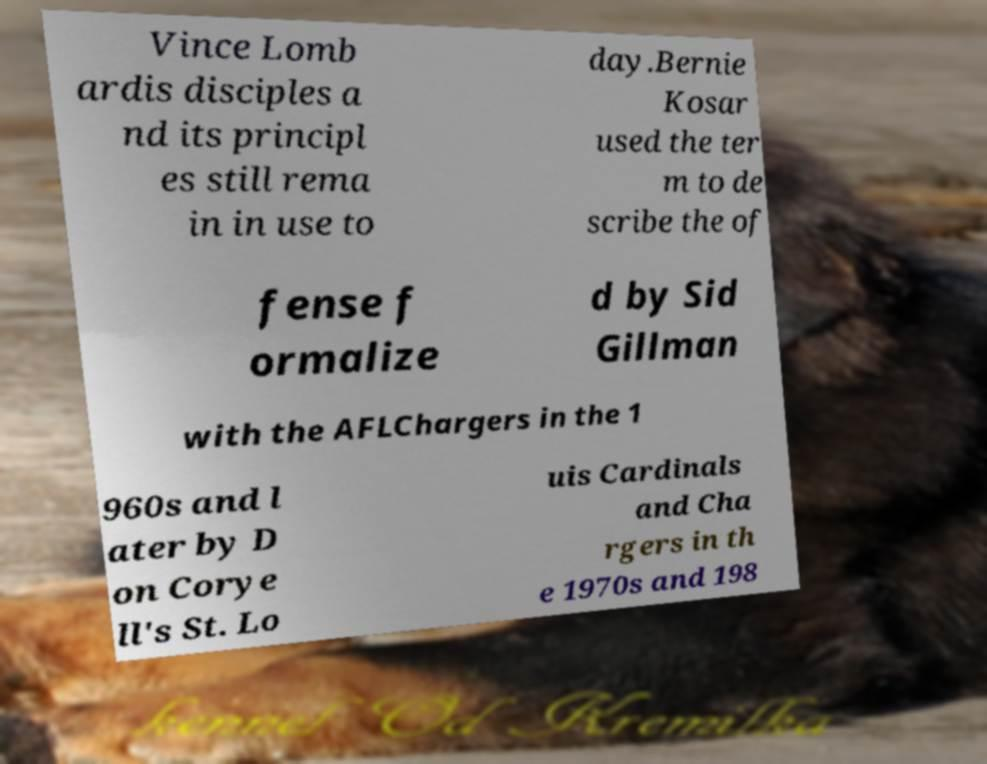Can you read and provide the text displayed in the image?This photo seems to have some interesting text. Can you extract and type it out for me? Vince Lomb ardis disciples a nd its principl es still rema in in use to day.Bernie Kosar used the ter m to de scribe the of fense f ormalize d by Sid Gillman with the AFLChargers in the 1 960s and l ater by D on Corye ll's St. Lo uis Cardinals and Cha rgers in th e 1970s and 198 